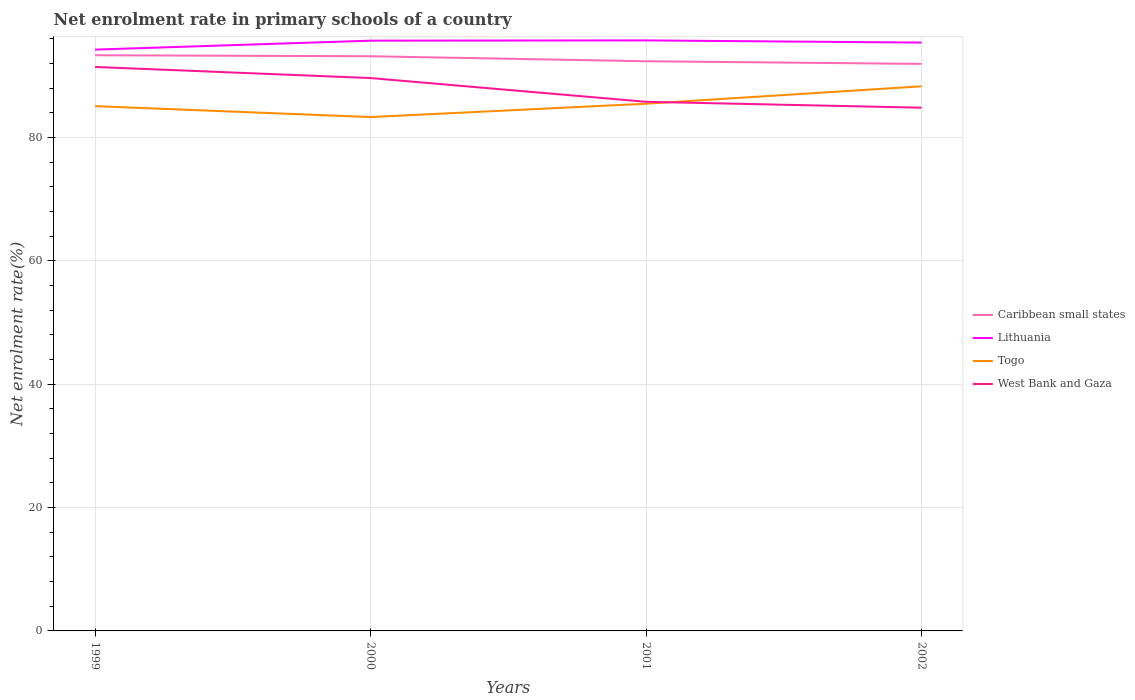How many different coloured lines are there?
Offer a very short reply. 4. Across all years, what is the maximum net enrolment rate in primary schools in Caribbean small states?
Make the answer very short. 91.91. In which year was the net enrolment rate in primary schools in Lithuania maximum?
Offer a terse response. 1999. What is the total net enrolment rate in primary schools in Togo in the graph?
Provide a succinct answer. -3.21. What is the difference between the highest and the second highest net enrolment rate in primary schools in Caribbean small states?
Your answer should be very brief. 1.4. Is the net enrolment rate in primary schools in Caribbean small states strictly greater than the net enrolment rate in primary schools in Togo over the years?
Keep it short and to the point. No. How many lines are there?
Provide a short and direct response. 4. How many years are there in the graph?
Offer a very short reply. 4. Are the values on the major ticks of Y-axis written in scientific E-notation?
Make the answer very short. No. Does the graph contain any zero values?
Ensure brevity in your answer.  No. How are the legend labels stacked?
Your answer should be compact. Vertical. What is the title of the graph?
Provide a succinct answer. Net enrolment rate in primary schools of a country. What is the label or title of the Y-axis?
Keep it short and to the point. Net enrolment rate(%). What is the Net enrolment rate(%) of Caribbean small states in 1999?
Offer a very short reply. 93.31. What is the Net enrolment rate(%) in Lithuania in 1999?
Keep it short and to the point. 94.23. What is the Net enrolment rate(%) of Togo in 1999?
Keep it short and to the point. 85.06. What is the Net enrolment rate(%) in West Bank and Gaza in 1999?
Your response must be concise. 91.42. What is the Net enrolment rate(%) in Caribbean small states in 2000?
Make the answer very short. 93.15. What is the Net enrolment rate(%) of Lithuania in 2000?
Make the answer very short. 95.68. What is the Net enrolment rate(%) in Togo in 2000?
Your answer should be compact. 83.29. What is the Net enrolment rate(%) of West Bank and Gaza in 2000?
Your response must be concise. 89.61. What is the Net enrolment rate(%) of Caribbean small states in 2001?
Your answer should be very brief. 92.34. What is the Net enrolment rate(%) in Lithuania in 2001?
Keep it short and to the point. 95.72. What is the Net enrolment rate(%) in Togo in 2001?
Offer a terse response. 85.45. What is the Net enrolment rate(%) in West Bank and Gaza in 2001?
Give a very brief answer. 85.77. What is the Net enrolment rate(%) of Caribbean small states in 2002?
Keep it short and to the point. 91.91. What is the Net enrolment rate(%) in Lithuania in 2002?
Make the answer very short. 95.37. What is the Net enrolment rate(%) in Togo in 2002?
Provide a short and direct response. 88.28. What is the Net enrolment rate(%) of West Bank and Gaza in 2002?
Your response must be concise. 84.81. Across all years, what is the maximum Net enrolment rate(%) of Caribbean small states?
Offer a very short reply. 93.31. Across all years, what is the maximum Net enrolment rate(%) of Lithuania?
Make the answer very short. 95.72. Across all years, what is the maximum Net enrolment rate(%) of Togo?
Provide a short and direct response. 88.28. Across all years, what is the maximum Net enrolment rate(%) in West Bank and Gaza?
Give a very brief answer. 91.42. Across all years, what is the minimum Net enrolment rate(%) in Caribbean small states?
Provide a succinct answer. 91.91. Across all years, what is the minimum Net enrolment rate(%) of Lithuania?
Keep it short and to the point. 94.23. Across all years, what is the minimum Net enrolment rate(%) of Togo?
Offer a very short reply. 83.29. Across all years, what is the minimum Net enrolment rate(%) in West Bank and Gaza?
Make the answer very short. 84.81. What is the total Net enrolment rate(%) of Caribbean small states in the graph?
Offer a very short reply. 370.71. What is the total Net enrolment rate(%) of Lithuania in the graph?
Offer a terse response. 380.99. What is the total Net enrolment rate(%) of Togo in the graph?
Make the answer very short. 342.09. What is the total Net enrolment rate(%) of West Bank and Gaza in the graph?
Keep it short and to the point. 351.61. What is the difference between the Net enrolment rate(%) in Caribbean small states in 1999 and that in 2000?
Ensure brevity in your answer.  0.16. What is the difference between the Net enrolment rate(%) in Lithuania in 1999 and that in 2000?
Give a very brief answer. -1.45. What is the difference between the Net enrolment rate(%) in Togo in 1999 and that in 2000?
Provide a succinct answer. 1.77. What is the difference between the Net enrolment rate(%) of West Bank and Gaza in 1999 and that in 2000?
Your answer should be very brief. 1.8. What is the difference between the Net enrolment rate(%) in Caribbean small states in 1999 and that in 2001?
Give a very brief answer. 0.97. What is the difference between the Net enrolment rate(%) of Lithuania in 1999 and that in 2001?
Provide a short and direct response. -1.49. What is the difference between the Net enrolment rate(%) of Togo in 1999 and that in 2001?
Provide a succinct answer. -0.39. What is the difference between the Net enrolment rate(%) of West Bank and Gaza in 1999 and that in 2001?
Give a very brief answer. 5.65. What is the difference between the Net enrolment rate(%) in Caribbean small states in 1999 and that in 2002?
Ensure brevity in your answer.  1.4. What is the difference between the Net enrolment rate(%) in Lithuania in 1999 and that in 2002?
Give a very brief answer. -1.14. What is the difference between the Net enrolment rate(%) in Togo in 1999 and that in 2002?
Make the answer very short. -3.21. What is the difference between the Net enrolment rate(%) of West Bank and Gaza in 1999 and that in 2002?
Provide a succinct answer. 6.61. What is the difference between the Net enrolment rate(%) in Caribbean small states in 2000 and that in 2001?
Offer a terse response. 0.81. What is the difference between the Net enrolment rate(%) of Lithuania in 2000 and that in 2001?
Make the answer very short. -0.04. What is the difference between the Net enrolment rate(%) of Togo in 2000 and that in 2001?
Provide a succinct answer. -2.16. What is the difference between the Net enrolment rate(%) of West Bank and Gaza in 2000 and that in 2001?
Provide a succinct answer. 3.85. What is the difference between the Net enrolment rate(%) in Caribbean small states in 2000 and that in 2002?
Ensure brevity in your answer.  1.24. What is the difference between the Net enrolment rate(%) of Lithuania in 2000 and that in 2002?
Offer a very short reply. 0.31. What is the difference between the Net enrolment rate(%) in Togo in 2000 and that in 2002?
Your answer should be compact. -4.98. What is the difference between the Net enrolment rate(%) of West Bank and Gaza in 2000 and that in 2002?
Provide a short and direct response. 4.81. What is the difference between the Net enrolment rate(%) in Caribbean small states in 2001 and that in 2002?
Your answer should be very brief. 0.43. What is the difference between the Net enrolment rate(%) of Lithuania in 2001 and that in 2002?
Your answer should be very brief. 0.35. What is the difference between the Net enrolment rate(%) of Togo in 2001 and that in 2002?
Offer a terse response. -2.82. What is the difference between the Net enrolment rate(%) of West Bank and Gaza in 2001 and that in 2002?
Offer a terse response. 0.96. What is the difference between the Net enrolment rate(%) of Caribbean small states in 1999 and the Net enrolment rate(%) of Lithuania in 2000?
Your response must be concise. -2.36. What is the difference between the Net enrolment rate(%) of Caribbean small states in 1999 and the Net enrolment rate(%) of Togo in 2000?
Your answer should be compact. 10.02. What is the difference between the Net enrolment rate(%) of Caribbean small states in 1999 and the Net enrolment rate(%) of West Bank and Gaza in 2000?
Ensure brevity in your answer.  3.7. What is the difference between the Net enrolment rate(%) in Lithuania in 1999 and the Net enrolment rate(%) in Togo in 2000?
Keep it short and to the point. 10.93. What is the difference between the Net enrolment rate(%) of Lithuania in 1999 and the Net enrolment rate(%) of West Bank and Gaza in 2000?
Provide a short and direct response. 4.61. What is the difference between the Net enrolment rate(%) of Togo in 1999 and the Net enrolment rate(%) of West Bank and Gaza in 2000?
Offer a terse response. -4.55. What is the difference between the Net enrolment rate(%) of Caribbean small states in 1999 and the Net enrolment rate(%) of Lithuania in 2001?
Provide a succinct answer. -2.41. What is the difference between the Net enrolment rate(%) in Caribbean small states in 1999 and the Net enrolment rate(%) in Togo in 2001?
Provide a succinct answer. 7.86. What is the difference between the Net enrolment rate(%) in Caribbean small states in 1999 and the Net enrolment rate(%) in West Bank and Gaza in 2001?
Your response must be concise. 7.54. What is the difference between the Net enrolment rate(%) in Lithuania in 1999 and the Net enrolment rate(%) in Togo in 2001?
Give a very brief answer. 8.77. What is the difference between the Net enrolment rate(%) of Lithuania in 1999 and the Net enrolment rate(%) of West Bank and Gaza in 2001?
Ensure brevity in your answer.  8.46. What is the difference between the Net enrolment rate(%) in Togo in 1999 and the Net enrolment rate(%) in West Bank and Gaza in 2001?
Your response must be concise. -0.71. What is the difference between the Net enrolment rate(%) in Caribbean small states in 1999 and the Net enrolment rate(%) in Lithuania in 2002?
Offer a very short reply. -2.05. What is the difference between the Net enrolment rate(%) of Caribbean small states in 1999 and the Net enrolment rate(%) of Togo in 2002?
Keep it short and to the point. 5.04. What is the difference between the Net enrolment rate(%) of Caribbean small states in 1999 and the Net enrolment rate(%) of West Bank and Gaza in 2002?
Your response must be concise. 8.5. What is the difference between the Net enrolment rate(%) of Lithuania in 1999 and the Net enrolment rate(%) of Togo in 2002?
Ensure brevity in your answer.  5.95. What is the difference between the Net enrolment rate(%) of Lithuania in 1999 and the Net enrolment rate(%) of West Bank and Gaza in 2002?
Keep it short and to the point. 9.42. What is the difference between the Net enrolment rate(%) of Togo in 1999 and the Net enrolment rate(%) of West Bank and Gaza in 2002?
Offer a very short reply. 0.25. What is the difference between the Net enrolment rate(%) of Caribbean small states in 2000 and the Net enrolment rate(%) of Lithuania in 2001?
Give a very brief answer. -2.57. What is the difference between the Net enrolment rate(%) in Caribbean small states in 2000 and the Net enrolment rate(%) in Togo in 2001?
Offer a terse response. 7.69. What is the difference between the Net enrolment rate(%) of Caribbean small states in 2000 and the Net enrolment rate(%) of West Bank and Gaza in 2001?
Offer a very short reply. 7.38. What is the difference between the Net enrolment rate(%) in Lithuania in 2000 and the Net enrolment rate(%) in Togo in 2001?
Give a very brief answer. 10.22. What is the difference between the Net enrolment rate(%) of Lithuania in 2000 and the Net enrolment rate(%) of West Bank and Gaza in 2001?
Your response must be concise. 9.91. What is the difference between the Net enrolment rate(%) of Togo in 2000 and the Net enrolment rate(%) of West Bank and Gaza in 2001?
Your response must be concise. -2.47. What is the difference between the Net enrolment rate(%) of Caribbean small states in 2000 and the Net enrolment rate(%) of Lithuania in 2002?
Your response must be concise. -2.22. What is the difference between the Net enrolment rate(%) in Caribbean small states in 2000 and the Net enrolment rate(%) in Togo in 2002?
Give a very brief answer. 4.87. What is the difference between the Net enrolment rate(%) of Caribbean small states in 2000 and the Net enrolment rate(%) of West Bank and Gaza in 2002?
Your answer should be compact. 8.34. What is the difference between the Net enrolment rate(%) of Lithuania in 2000 and the Net enrolment rate(%) of Togo in 2002?
Keep it short and to the point. 7.4. What is the difference between the Net enrolment rate(%) in Lithuania in 2000 and the Net enrolment rate(%) in West Bank and Gaza in 2002?
Your answer should be compact. 10.87. What is the difference between the Net enrolment rate(%) in Togo in 2000 and the Net enrolment rate(%) in West Bank and Gaza in 2002?
Provide a succinct answer. -1.52. What is the difference between the Net enrolment rate(%) of Caribbean small states in 2001 and the Net enrolment rate(%) of Lithuania in 2002?
Offer a very short reply. -3.02. What is the difference between the Net enrolment rate(%) of Caribbean small states in 2001 and the Net enrolment rate(%) of Togo in 2002?
Your response must be concise. 4.06. What is the difference between the Net enrolment rate(%) in Caribbean small states in 2001 and the Net enrolment rate(%) in West Bank and Gaza in 2002?
Your response must be concise. 7.53. What is the difference between the Net enrolment rate(%) of Lithuania in 2001 and the Net enrolment rate(%) of Togo in 2002?
Give a very brief answer. 7.44. What is the difference between the Net enrolment rate(%) in Lithuania in 2001 and the Net enrolment rate(%) in West Bank and Gaza in 2002?
Your answer should be very brief. 10.91. What is the difference between the Net enrolment rate(%) of Togo in 2001 and the Net enrolment rate(%) of West Bank and Gaza in 2002?
Provide a short and direct response. 0.65. What is the average Net enrolment rate(%) of Caribbean small states per year?
Your answer should be compact. 92.68. What is the average Net enrolment rate(%) in Lithuania per year?
Offer a very short reply. 95.25. What is the average Net enrolment rate(%) of Togo per year?
Your answer should be compact. 85.52. What is the average Net enrolment rate(%) of West Bank and Gaza per year?
Give a very brief answer. 87.9. In the year 1999, what is the difference between the Net enrolment rate(%) in Caribbean small states and Net enrolment rate(%) in Lithuania?
Your answer should be very brief. -0.91. In the year 1999, what is the difference between the Net enrolment rate(%) of Caribbean small states and Net enrolment rate(%) of Togo?
Your answer should be compact. 8.25. In the year 1999, what is the difference between the Net enrolment rate(%) in Caribbean small states and Net enrolment rate(%) in West Bank and Gaza?
Offer a very short reply. 1.89. In the year 1999, what is the difference between the Net enrolment rate(%) in Lithuania and Net enrolment rate(%) in Togo?
Make the answer very short. 9.16. In the year 1999, what is the difference between the Net enrolment rate(%) of Lithuania and Net enrolment rate(%) of West Bank and Gaza?
Give a very brief answer. 2.81. In the year 1999, what is the difference between the Net enrolment rate(%) in Togo and Net enrolment rate(%) in West Bank and Gaza?
Give a very brief answer. -6.36. In the year 2000, what is the difference between the Net enrolment rate(%) of Caribbean small states and Net enrolment rate(%) of Lithuania?
Your answer should be very brief. -2.53. In the year 2000, what is the difference between the Net enrolment rate(%) of Caribbean small states and Net enrolment rate(%) of Togo?
Keep it short and to the point. 9.86. In the year 2000, what is the difference between the Net enrolment rate(%) in Caribbean small states and Net enrolment rate(%) in West Bank and Gaza?
Keep it short and to the point. 3.53. In the year 2000, what is the difference between the Net enrolment rate(%) of Lithuania and Net enrolment rate(%) of Togo?
Offer a very short reply. 12.38. In the year 2000, what is the difference between the Net enrolment rate(%) of Lithuania and Net enrolment rate(%) of West Bank and Gaza?
Provide a succinct answer. 6.06. In the year 2000, what is the difference between the Net enrolment rate(%) of Togo and Net enrolment rate(%) of West Bank and Gaza?
Offer a terse response. -6.32. In the year 2001, what is the difference between the Net enrolment rate(%) of Caribbean small states and Net enrolment rate(%) of Lithuania?
Your answer should be very brief. -3.38. In the year 2001, what is the difference between the Net enrolment rate(%) in Caribbean small states and Net enrolment rate(%) in Togo?
Your answer should be compact. 6.89. In the year 2001, what is the difference between the Net enrolment rate(%) of Caribbean small states and Net enrolment rate(%) of West Bank and Gaza?
Provide a succinct answer. 6.57. In the year 2001, what is the difference between the Net enrolment rate(%) of Lithuania and Net enrolment rate(%) of Togo?
Offer a very short reply. 10.26. In the year 2001, what is the difference between the Net enrolment rate(%) of Lithuania and Net enrolment rate(%) of West Bank and Gaza?
Offer a terse response. 9.95. In the year 2001, what is the difference between the Net enrolment rate(%) in Togo and Net enrolment rate(%) in West Bank and Gaza?
Provide a succinct answer. -0.31. In the year 2002, what is the difference between the Net enrolment rate(%) in Caribbean small states and Net enrolment rate(%) in Lithuania?
Ensure brevity in your answer.  -3.45. In the year 2002, what is the difference between the Net enrolment rate(%) in Caribbean small states and Net enrolment rate(%) in Togo?
Your response must be concise. 3.64. In the year 2002, what is the difference between the Net enrolment rate(%) of Caribbean small states and Net enrolment rate(%) of West Bank and Gaza?
Provide a succinct answer. 7.1. In the year 2002, what is the difference between the Net enrolment rate(%) in Lithuania and Net enrolment rate(%) in Togo?
Provide a succinct answer. 7.09. In the year 2002, what is the difference between the Net enrolment rate(%) of Lithuania and Net enrolment rate(%) of West Bank and Gaza?
Your response must be concise. 10.56. In the year 2002, what is the difference between the Net enrolment rate(%) in Togo and Net enrolment rate(%) in West Bank and Gaza?
Provide a short and direct response. 3.47. What is the ratio of the Net enrolment rate(%) of Caribbean small states in 1999 to that in 2000?
Offer a very short reply. 1. What is the ratio of the Net enrolment rate(%) of Lithuania in 1999 to that in 2000?
Offer a terse response. 0.98. What is the ratio of the Net enrolment rate(%) in Togo in 1999 to that in 2000?
Your answer should be very brief. 1.02. What is the ratio of the Net enrolment rate(%) of West Bank and Gaza in 1999 to that in 2000?
Your response must be concise. 1.02. What is the ratio of the Net enrolment rate(%) of Caribbean small states in 1999 to that in 2001?
Give a very brief answer. 1.01. What is the ratio of the Net enrolment rate(%) in Lithuania in 1999 to that in 2001?
Offer a very short reply. 0.98. What is the ratio of the Net enrolment rate(%) of Togo in 1999 to that in 2001?
Offer a very short reply. 1. What is the ratio of the Net enrolment rate(%) of West Bank and Gaza in 1999 to that in 2001?
Give a very brief answer. 1.07. What is the ratio of the Net enrolment rate(%) of Caribbean small states in 1999 to that in 2002?
Provide a short and direct response. 1.02. What is the ratio of the Net enrolment rate(%) in Togo in 1999 to that in 2002?
Your response must be concise. 0.96. What is the ratio of the Net enrolment rate(%) of West Bank and Gaza in 1999 to that in 2002?
Provide a succinct answer. 1.08. What is the ratio of the Net enrolment rate(%) in Caribbean small states in 2000 to that in 2001?
Provide a succinct answer. 1.01. What is the ratio of the Net enrolment rate(%) in Lithuania in 2000 to that in 2001?
Your response must be concise. 1. What is the ratio of the Net enrolment rate(%) in Togo in 2000 to that in 2001?
Give a very brief answer. 0.97. What is the ratio of the Net enrolment rate(%) in West Bank and Gaza in 2000 to that in 2001?
Make the answer very short. 1.04. What is the ratio of the Net enrolment rate(%) of Caribbean small states in 2000 to that in 2002?
Ensure brevity in your answer.  1.01. What is the ratio of the Net enrolment rate(%) in Lithuania in 2000 to that in 2002?
Keep it short and to the point. 1. What is the ratio of the Net enrolment rate(%) in Togo in 2000 to that in 2002?
Offer a very short reply. 0.94. What is the ratio of the Net enrolment rate(%) of West Bank and Gaza in 2000 to that in 2002?
Your answer should be very brief. 1.06. What is the ratio of the Net enrolment rate(%) in Lithuania in 2001 to that in 2002?
Your answer should be compact. 1. What is the ratio of the Net enrolment rate(%) of West Bank and Gaza in 2001 to that in 2002?
Ensure brevity in your answer.  1.01. What is the difference between the highest and the second highest Net enrolment rate(%) in Caribbean small states?
Make the answer very short. 0.16. What is the difference between the highest and the second highest Net enrolment rate(%) in Lithuania?
Provide a short and direct response. 0.04. What is the difference between the highest and the second highest Net enrolment rate(%) in Togo?
Give a very brief answer. 2.82. What is the difference between the highest and the second highest Net enrolment rate(%) of West Bank and Gaza?
Give a very brief answer. 1.8. What is the difference between the highest and the lowest Net enrolment rate(%) in Caribbean small states?
Your answer should be very brief. 1.4. What is the difference between the highest and the lowest Net enrolment rate(%) in Lithuania?
Ensure brevity in your answer.  1.49. What is the difference between the highest and the lowest Net enrolment rate(%) in Togo?
Your answer should be very brief. 4.98. What is the difference between the highest and the lowest Net enrolment rate(%) of West Bank and Gaza?
Offer a very short reply. 6.61. 